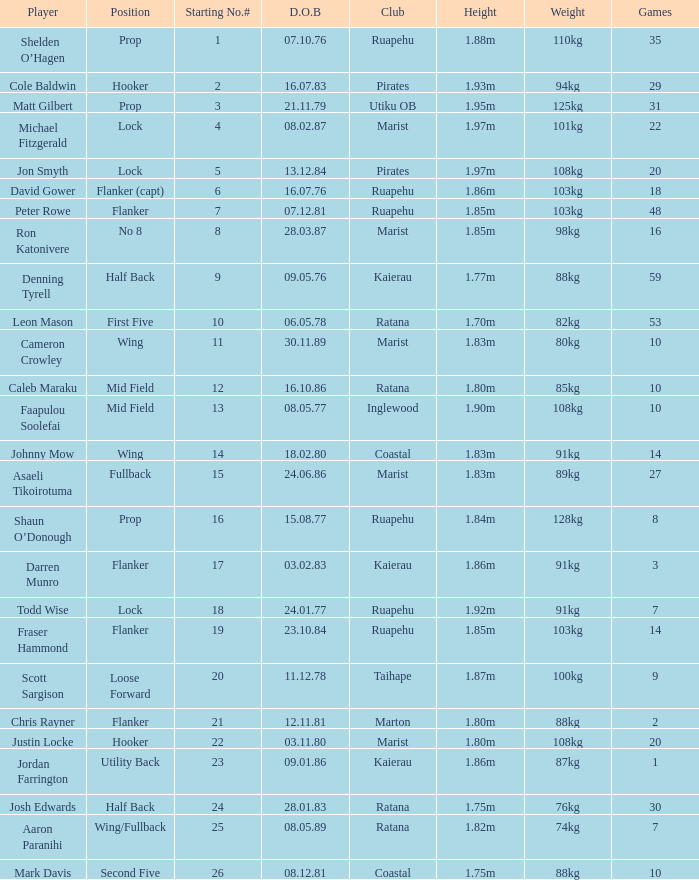What is the date of birth for the player in the Inglewood club? 80577.0. 